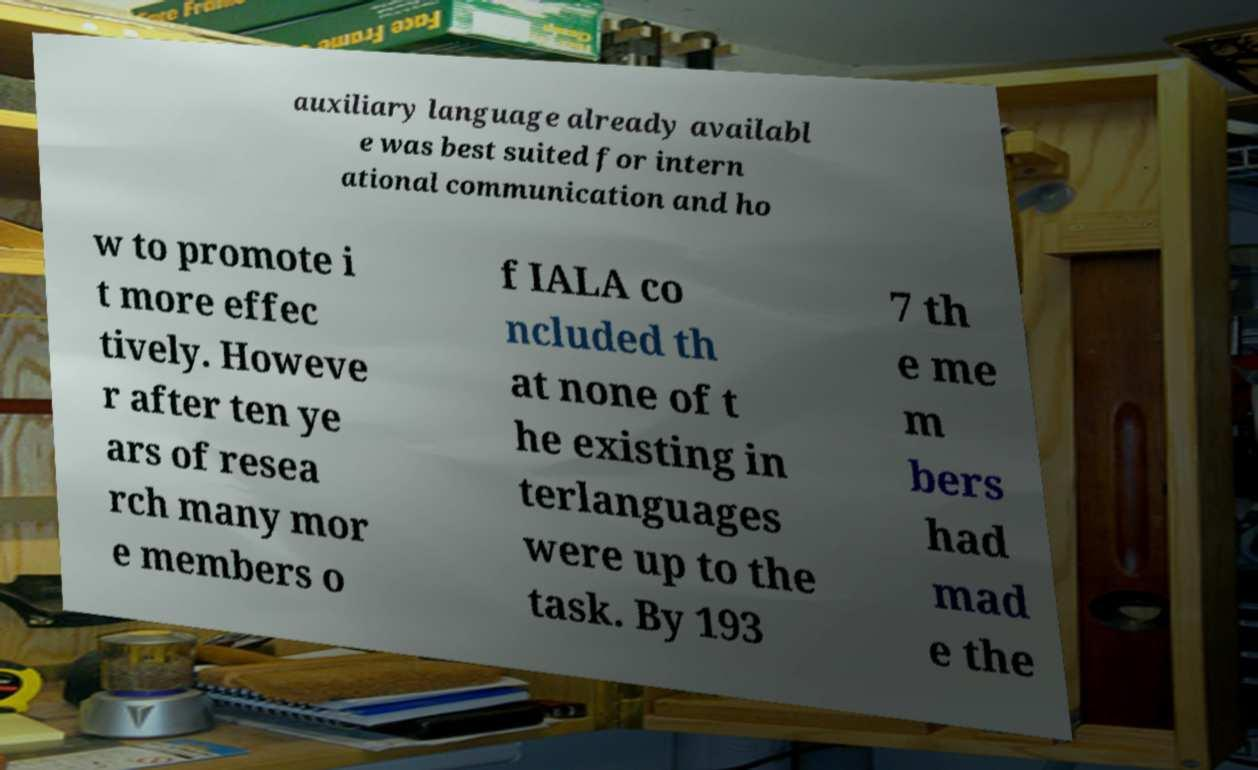I need the written content from this picture converted into text. Can you do that? auxiliary language already availabl e was best suited for intern ational communication and ho w to promote i t more effec tively. Howeve r after ten ye ars of resea rch many mor e members o f IALA co ncluded th at none of t he existing in terlanguages were up to the task. By 193 7 th e me m bers had mad e the 